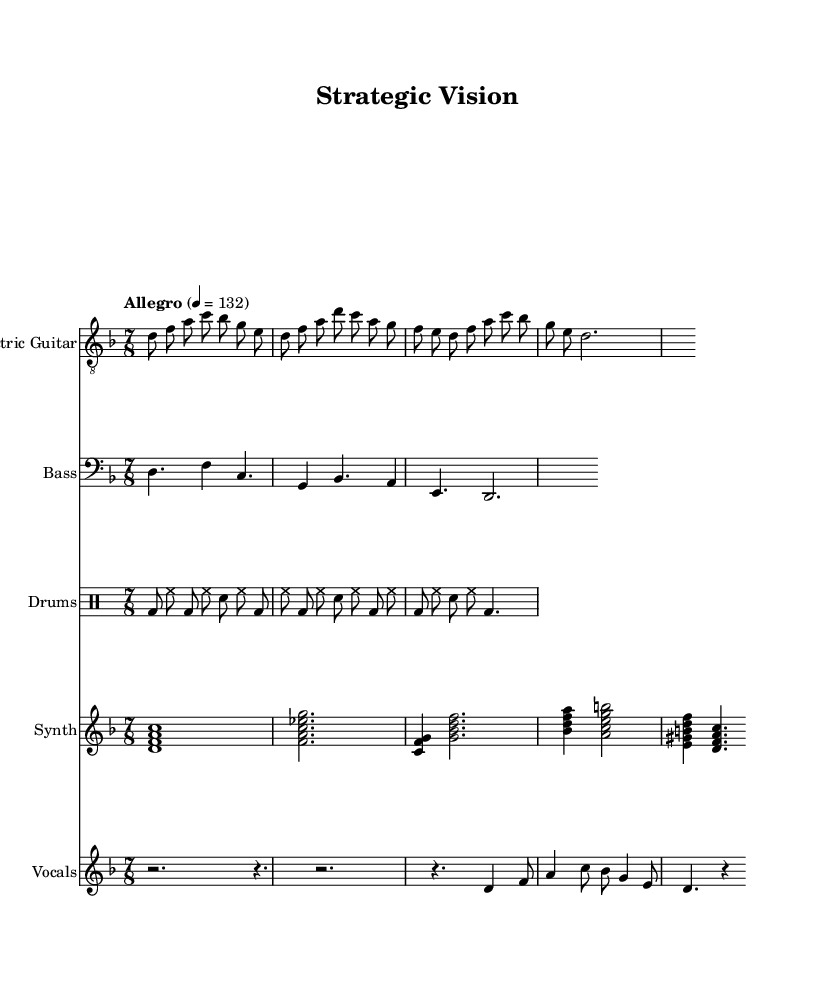What is the key signature of this music? The key signature in the sheet music indicates D minor, which has one flat. This is determined by the presence of the flat symbol on the B line at the start of the staff, indicating that B is lowered a half step.
Answer: D minor What is the time signature of this music? The time signature displayed in the sheet music is 7/8. This is indicated at the beginning of the score and is read as seven eighth notes per measure, which is commonly used in progressive rock to create complex rhythms.
Answer: 7/8 What is the tempo marking of this music? The tempo marking in the score specifies "Allegro" with a metronome marking of 132 beats per minute. This indicates that the piece should be played at a fast, lively pace.
Answer: Allegro, 132 Which instrument plays the main melody? The instrument that plays the main melody is the Electric Guitar, as indicated by the staff label in the music. Electric guitars typically carry the lead melodic lines in rock music, and this part is written in the treble clef.
Answer: Electric Guitar How many measures are in the drums part? The drums part consists of three complete measures, as seen in the drum staff where there are distinct groupings of beats corresponding to the time signature. Each line of the part is organized into measures clearly divided by vertical bar lines.
Answer: 3 What is the function of the synth chords in this arrangement? The synth chords, written in the piano staff, provide harmonic support and texture to the arrangement. They fill out the sound and contrast with the melodic lines of the guitar and vocals while aligning with the underlying business concept conveyed through the lyrics.
Answer: Harmonic support 